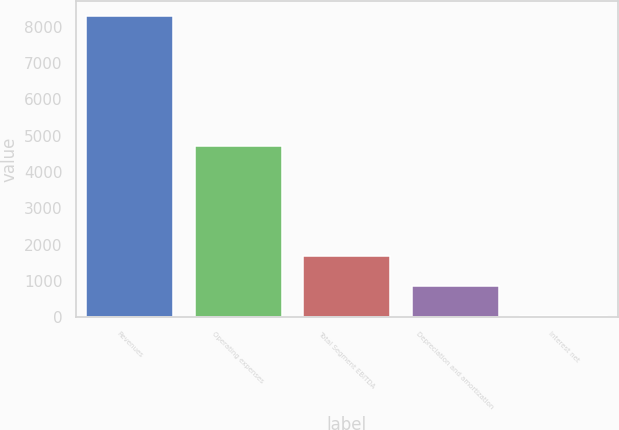<chart> <loc_0><loc_0><loc_500><loc_500><bar_chart><fcel>Revenues<fcel>Operating expenses<fcel>Total Segment EBITDA<fcel>Depreciation and amortization<fcel>Interest net<nl><fcel>8292<fcel>4728<fcel>1692.8<fcel>867.9<fcel>43<nl></chart> 